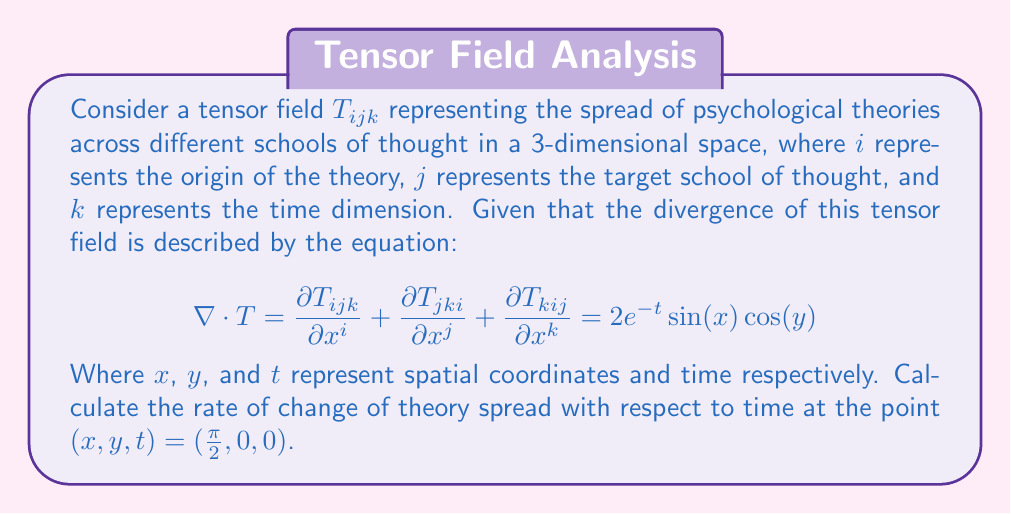Can you solve this math problem? To solve this problem, we'll follow these steps:

1) The divergence of the tensor field is given by:

   $$\nabla \cdot T = \frac{\partial T_{ijk}}{\partial x^i} + \frac{\partial T_{jki}}{\partial x^j} + \frac{\partial T_{kij}}{\partial x^k} = 2e^{-t}\sin(x)\cos(y)$$

2) We're interested in the rate of change with respect to time, which is represented by the partial derivative with respect to $t$. Let's call this $\frac{\partial}{\partial t}(\nabla \cdot T)$.

3) Taking the partial derivative of both sides with respect to $t$:

   $$\frac{\partial}{\partial t}(\nabla \cdot T) = \frac{\partial}{\partial t}(2e^{-t}\sin(x)\cos(y))$$

4) Using the chain rule:

   $$\frac{\partial}{\partial t}(\nabla \cdot T) = 2\sin(x)\cos(y) \cdot \frac{\partial}{\partial t}(e^{-t}) = -2e^{-t}\sin(x)\cos(y)$$

5) Now, we need to evaluate this at the point $(x,y,t) = (\frac{\pi}{2}, 0, 0)$:

   $$\left.\frac{\partial}{\partial t}(\nabla \cdot T)\right|_{(\frac{\pi}{2},0,0)} = -2e^{-0}\sin(\frac{\pi}{2})\cos(0)$$

6) Simplify:
   $$-2 \cdot 1 \cdot 1 \cdot 1 = -2$$

Thus, the rate of change of theory spread with respect to time at the point $(\frac{\pi}{2}, 0, 0)$ is $-2$.
Answer: $-2$ 